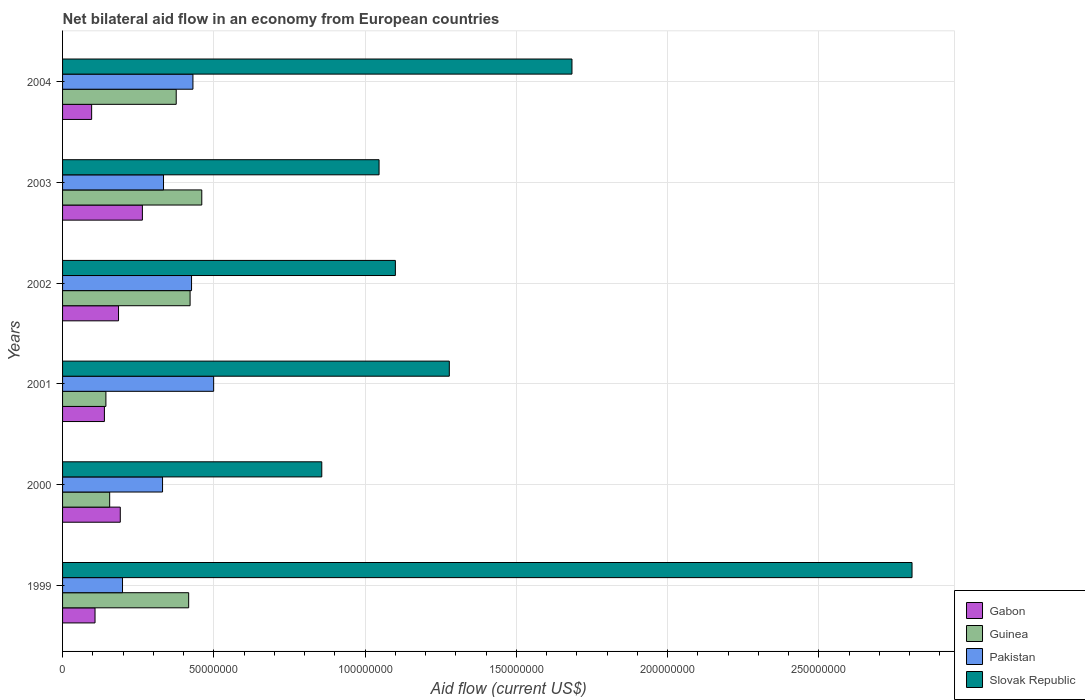How many groups of bars are there?
Provide a short and direct response. 6. Are the number of bars on each tick of the Y-axis equal?
Keep it short and to the point. Yes. How many bars are there on the 5th tick from the top?
Make the answer very short. 4. How many bars are there on the 5th tick from the bottom?
Your response must be concise. 4. In how many cases, is the number of bars for a given year not equal to the number of legend labels?
Your answer should be very brief. 0. What is the net bilateral aid flow in Slovak Republic in 2000?
Offer a very short reply. 8.57e+07. Across all years, what is the maximum net bilateral aid flow in Gabon?
Your answer should be very brief. 2.64e+07. Across all years, what is the minimum net bilateral aid flow in Guinea?
Provide a succinct answer. 1.43e+07. What is the total net bilateral aid flow in Gabon in the graph?
Provide a short and direct response. 9.81e+07. What is the difference between the net bilateral aid flow in Pakistan in 2003 and that in 2004?
Keep it short and to the point. -9.73e+06. What is the difference between the net bilateral aid flow in Pakistan in 2000 and the net bilateral aid flow in Slovak Republic in 2001?
Provide a succinct answer. -9.48e+07. What is the average net bilateral aid flow in Slovak Republic per year?
Your answer should be compact. 1.46e+08. In the year 2000, what is the difference between the net bilateral aid flow in Pakistan and net bilateral aid flow in Gabon?
Make the answer very short. 1.40e+07. In how many years, is the net bilateral aid flow in Guinea greater than 250000000 US$?
Your answer should be very brief. 0. What is the ratio of the net bilateral aid flow in Guinea in 2000 to that in 2001?
Your response must be concise. 1.09. Is the net bilateral aid flow in Slovak Republic in 2000 less than that in 2002?
Make the answer very short. Yes. Is the difference between the net bilateral aid flow in Pakistan in 2001 and 2003 greater than the difference between the net bilateral aid flow in Gabon in 2001 and 2003?
Provide a succinct answer. Yes. What is the difference between the highest and the second highest net bilateral aid flow in Slovak Republic?
Keep it short and to the point. 1.12e+08. What is the difference between the highest and the lowest net bilateral aid flow in Guinea?
Provide a short and direct response. 3.17e+07. In how many years, is the net bilateral aid flow in Slovak Republic greater than the average net bilateral aid flow in Slovak Republic taken over all years?
Provide a short and direct response. 2. Is the sum of the net bilateral aid flow in Slovak Republic in 2000 and 2003 greater than the maximum net bilateral aid flow in Pakistan across all years?
Give a very brief answer. Yes. Is it the case that in every year, the sum of the net bilateral aid flow in Guinea and net bilateral aid flow in Slovak Republic is greater than the sum of net bilateral aid flow in Gabon and net bilateral aid flow in Pakistan?
Offer a very short reply. Yes. What does the 3rd bar from the top in 2004 represents?
Keep it short and to the point. Guinea. What does the 4th bar from the bottom in 2003 represents?
Ensure brevity in your answer.  Slovak Republic. How many bars are there?
Provide a short and direct response. 24. Are all the bars in the graph horizontal?
Offer a very short reply. Yes. How many years are there in the graph?
Make the answer very short. 6. Are the values on the major ticks of X-axis written in scientific E-notation?
Keep it short and to the point. No. Where does the legend appear in the graph?
Offer a very short reply. Bottom right. How many legend labels are there?
Provide a succinct answer. 4. What is the title of the graph?
Ensure brevity in your answer.  Net bilateral aid flow in an economy from European countries. Does "Russian Federation" appear as one of the legend labels in the graph?
Your answer should be very brief. No. What is the Aid flow (current US$) of Gabon in 1999?
Your answer should be compact. 1.07e+07. What is the Aid flow (current US$) in Guinea in 1999?
Your answer should be compact. 4.17e+07. What is the Aid flow (current US$) of Pakistan in 1999?
Offer a very short reply. 1.98e+07. What is the Aid flow (current US$) in Slovak Republic in 1999?
Provide a short and direct response. 2.81e+08. What is the Aid flow (current US$) of Gabon in 2000?
Your answer should be very brief. 1.91e+07. What is the Aid flow (current US$) of Guinea in 2000?
Your answer should be compact. 1.56e+07. What is the Aid flow (current US$) of Pakistan in 2000?
Give a very brief answer. 3.30e+07. What is the Aid flow (current US$) in Slovak Republic in 2000?
Make the answer very short. 8.57e+07. What is the Aid flow (current US$) of Gabon in 2001?
Give a very brief answer. 1.38e+07. What is the Aid flow (current US$) of Guinea in 2001?
Your answer should be compact. 1.43e+07. What is the Aid flow (current US$) of Pakistan in 2001?
Offer a very short reply. 5.00e+07. What is the Aid flow (current US$) in Slovak Republic in 2001?
Give a very brief answer. 1.28e+08. What is the Aid flow (current US$) in Gabon in 2002?
Your answer should be compact. 1.85e+07. What is the Aid flow (current US$) in Guinea in 2002?
Offer a terse response. 4.22e+07. What is the Aid flow (current US$) of Pakistan in 2002?
Make the answer very short. 4.26e+07. What is the Aid flow (current US$) in Slovak Republic in 2002?
Provide a short and direct response. 1.10e+08. What is the Aid flow (current US$) of Gabon in 2003?
Your response must be concise. 2.64e+07. What is the Aid flow (current US$) in Guinea in 2003?
Offer a very short reply. 4.60e+07. What is the Aid flow (current US$) in Pakistan in 2003?
Provide a succinct answer. 3.34e+07. What is the Aid flow (current US$) in Slovak Republic in 2003?
Offer a terse response. 1.05e+08. What is the Aid flow (current US$) of Gabon in 2004?
Keep it short and to the point. 9.61e+06. What is the Aid flow (current US$) in Guinea in 2004?
Your response must be concise. 3.76e+07. What is the Aid flow (current US$) of Pakistan in 2004?
Your response must be concise. 4.31e+07. What is the Aid flow (current US$) in Slovak Republic in 2004?
Offer a terse response. 1.68e+08. Across all years, what is the maximum Aid flow (current US$) of Gabon?
Your answer should be very brief. 2.64e+07. Across all years, what is the maximum Aid flow (current US$) of Guinea?
Keep it short and to the point. 4.60e+07. Across all years, what is the maximum Aid flow (current US$) in Pakistan?
Offer a very short reply. 5.00e+07. Across all years, what is the maximum Aid flow (current US$) of Slovak Republic?
Offer a terse response. 2.81e+08. Across all years, what is the minimum Aid flow (current US$) of Gabon?
Offer a very short reply. 9.61e+06. Across all years, what is the minimum Aid flow (current US$) in Guinea?
Keep it short and to the point. 1.43e+07. Across all years, what is the minimum Aid flow (current US$) in Pakistan?
Your response must be concise. 1.98e+07. Across all years, what is the minimum Aid flow (current US$) in Slovak Republic?
Your answer should be very brief. 8.57e+07. What is the total Aid flow (current US$) in Gabon in the graph?
Give a very brief answer. 9.81e+07. What is the total Aid flow (current US$) in Guinea in the graph?
Offer a very short reply. 1.97e+08. What is the total Aid flow (current US$) in Pakistan in the graph?
Your answer should be very brief. 2.22e+08. What is the total Aid flow (current US$) of Slovak Republic in the graph?
Offer a terse response. 8.77e+08. What is the difference between the Aid flow (current US$) in Gabon in 1999 and that in 2000?
Your answer should be compact. -8.35e+06. What is the difference between the Aid flow (current US$) in Guinea in 1999 and that in 2000?
Ensure brevity in your answer.  2.61e+07. What is the difference between the Aid flow (current US$) in Pakistan in 1999 and that in 2000?
Your answer should be compact. -1.32e+07. What is the difference between the Aid flow (current US$) in Slovak Republic in 1999 and that in 2000?
Provide a short and direct response. 1.95e+08. What is the difference between the Aid flow (current US$) of Gabon in 1999 and that in 2001?
Your answer should be compact. -3.10e+06. What is the difference between the Aid flow (current US$) in Guinea in 1999 and that in 2001?
Make the answer very short. 2.74e+07. What is the difference between the Aid flow (current US$) of Pakistan in 1999 and that in 2001?
Ensure brevity in your answer.  -3.01e+07. What is the difference between the Aid flow (current US$) of Slovak Republic in 1999 and that in 2001?
Give a very brief answer. 1.53e+08. What is the difference between the Aid flow (current US$) of Gabon in 1999 and that in 2002?
Provide a succinct answer. -7.77e+06. What is the difference between the Aid flow (current US$) in Guinea in 1999 and that in 2002?
Keep it short and to the point. -4.70e+05. What is the difference between the Aid flow (current US$) of Pakistan in 1999 and that in 2002?
Offer a very short reply. -2.28e+07. What is the difference between the Aid flow (current US$) in Slovak Republic in 1999 and that in 2002?
Ensure brevity in your answer.  1.71e+08. What is the difference between the Aid flow (current US$) of Gabon in 1999 and that in 2003?
Ensure brevity in your answer.  -1.57e+07. What is the difference between the Aid flow (current US$) of Guinea in 1999 and that in 2003?
Provide a short and direct response. -4.33e+06. What is the difference between the Aid flow (current US$) in Pakistan in 1999 and that in 2003?
Your answer should be compact. -1.36e+07. What is the difference between the Aid flow (current US$) in Slovak Republic in 1999 and that in 2003?
Offer a terse response. 1.76e+08. What is the difference between the Aid flow (current US$) in Gabon in 1999 and that in 2004?
Provide a short and direct response. 1.12e+06. What is the difference between the Aid flow (current US$) of Guinea in 1999 and that in 2004?
Provide a short and direct response. 4.12e+06. What is the difference between the Aid flow (current US$) of Pakistan in 1999 and that in 2004?
Provide a succinct answer. -2.33e+07. What is the difference between the Aid flow (current US$) of Slovak Republic in 1999 and that in 2004?
Your answer should be compact. 1.12e+08. What is the difference between the Aid flow (current US$) in Gabon in 2000 and that in 2001?
Give a very brief answer. 5.25e+06. What is the difference between the Aid flow (current US$) of Guinea in 2000 and that in 2001?
Your answer should be very brief. 1.24e+06. What is the difference between the Aid flow (current US$) of Pakistan in 2000 and that in 2001?
Provide a short and direct response. -1.69e+07. What is the difference between the Aid flow (current US$) in Slovak Republic in 2000 and that in 2001?
Provide a short and direct response. -4.22e+07. What is the difference between the Aid flow (current US$) of Gabon in 2000 and that in 2002?
Make the answer very short. 5.80e+05. What is the difference between the Aid flow (current US$) in Guinea in 2000 and that in 2002?
Provide a succinct answer. -2.66e+07. What is the difference between the Aid flow (current US$) in Pakistan in 2000 and that in 2002?
Your answer should be very brief. -9.59e+06. What is the difference between the Aid flow (current US$) of Slovak Republic in 2000 and that in 2002?
Make the answer very short. -2.43e+07. What is the difference between the Aid flow (current US$) in Gabon in 2000 and that in 2003?
Give a very brief answer. -7.31e+06. What is the difference between the Aid flow (current US$) of Guinea in 2000 and that in 2003?
Offer a terse response. -3.04e+07. What is the difference between the Aid flow (current US$) in Pakistan in 2000 and that in 2003?
Make the answer very short. -3.20e+05. What is the difference between the Aid flow (current US$) in Slovak Republic in 2000 and that in 2003?
Keep it short and to the point. -1.89e+07. What is the difference between the Aid flow (current US$) in Gabon in 2000 and that in 2004?
Ensure brevity in your answer.  9.47e+06. What is the difference between the Aid flow (current US$) in Guinea in 2000 and that in 2004?
Provide a succinct answer. -2.20e+07. What is the difference between the Aid flow (current US$) of Pakistan in 2000 and that in 2004?
Your response must be concise. -1.00e+07. What is the difference between the Aid flow (current US$) of Slovak Republic in 2000 and that in 2004?
Keep it short and to the point. -8.27e+07. What is the difference between the Aid flow (current US$) in Gabon in 2001 and that in 2002?
Provide a succinct answer. -4.67e+06. What is the difference between the Aid flow (current US$) in Guinea in 2001 and that in 2002?
Your answer should be very brief. -2.78e+07. What is the difference between the Aid flow (current US$) in Pakistan in 2001 and that in 2002?
Ensure brevity in your answer.  7.31e+06. What is the difference between the Aid flow (current US$) of Slovak Republic in 2001 and that in 2002?
Your answer should be compact. 1.78e+07. What is the difference between the Aid flow (current US$) of Gabon in 2001 and that in 2003?
Make the answer very short. -1.26e+07. What is the difference between the Aid flow (current US$) in Guinea in 2001 and that in 2003?
Offer a terse response. -3.17e+07. What is the difference between the Aid flow (current US$) in Pakistan in 2001 and that in 2003?
Your response must be concise. 1.66e+07. What is the difference between the Aid flow (current US$) of Slovak Republic in 2001 and that in 2003?
Offer a terse response. 2.32e+07. What is the difference between the Aid flow (current US$) of Gabon in 2001 and that in 2004?
Provide a succinct answer. 4.22e+06. What is the difference between the Aid flow (current US$) of Guinea in 2001 and that in 2004?
Provide a short and direct response. -2.32e+07. What is the difference between the Aid flow (current US$) in Pakistan in 2001 and that in 2004?
Provide a short and direct response. 6.85e+06. What is the difference between the Aid flow (current US$) of Slovak Republic in 2001 and that in 2004?
Offer a very short reply. -4.06e+07. What is the difference between the Aid flow (current US$) of Gabon in 2002 and that in 2003?
Keep it short and to the point. -7.89e+06. What is the difference between the Aid flow (current US$) of Guinea in 2002 and that in 2003?
Provide a short and direct response. -3.86e+06. What is the difference between the Aid flow (current US$) in Pakistan in 2002 and that in 2003?
Keep it short and to the point. 9.27e+06. What is the difference between the Aid flow (current US$) in Slovak Republic in 2002 and that in 2003?
Provide a short and direct response. 5.39e+06. What is the difference between the Aid flow (current US$) of Gabon in 2002 and that in 2004?
Provide a succinct answer. 8.89e+06. What is the difference between the Aid flow (current US$) in Guinea in 2002 and that in 2004?
Give a very brief answer. 4.59e+06. What is the difference between the Aid flow (current US$) in Pakistan in 2002 and that in 2004?
Provide a short and direct response. -4.60e+05. What is the difference between the Aid flow (current US$) in Slovak Republic in 2002 and that in 2004?
Your answer should be very brief. -5.84e+07. What is the difference between the Aid flow (current US$) of Gabon in 2003 and that in 2004?
Offer a very short reply. 1.68e+07. What is the difference between the Aid flow (current US$) of Guinea in 2003 and that in 2004?
Keep it short and to the point. 8.45e+06. What is the difference between the Aid flow (current US$) in Pakistan in 2003 and that in 2004?
Ensure brevity in your answer.  -9.73e+06. What is the difference between the Aid flow (current US$) in Slovak Republic in 2003 and that in 2004?
Keep it short and to the point. -6.38e+07. What is the difference between the Aid flow (current US$) in Gabon in 1999 and the Aid flow (current US$) in Guinea in 2000?
Ensure brevity in your answer.  -4.84e+06. What is the difference between the Aid flow (current US$) of Gabon in 1999 and the Aid flow (current US$) of Pakistan in 2000?
Offer a very short reply. -2.23e+07. What is the difference between the Aid flow (current US$) of Gabon in 1999 and the Aid flow (current US$) of Slovak Republic in 2000?
Make the answer very short. -7.50e+07. What is the difference between the Aid flow (current US$) of Guinea in 1999 and the Aid flow (current US$) of Pakistan in 2000?
Your answer should be compact. 8.64e+06. What is the difference between the Aid flow (current US$) of Guinea in 1999 and the Aid flow (current US$) of Slovak Republic in 2000?
Offer a very short reply. -4.40e+07. What is the difference between the Aid flow (current US$) in Pakistan in 1999 and the Aid flow (current US$) in Slovak Republic in 2000?
Ensure brevity in your answer.  -6.59e+07. What is the difference between the Aid flow (current US$) in Gabon in 1999 and the Aid flow (current US$) in Guinea in 2001?
Provide a short and direct response. -3.60e+06. What is the difference between the Aid flow (current US$) in Gabon in 1999 and the Aid flow (current US$) in Pakistan in 2001?
Keep it short and to the point. -3.92e+07. What is the difference between the Aid flow (current US$) of Gabon in 1999 and the Aid flow (current US$) of Slovak Republic in 2001?
Provide a short and direct response. -1.17e+08. What is the difference between the Aid flow (current US$) in Guinea in 1999 and the Aid flow (current US$) in Pakistan in 2001?
Offer a very short reply. -8.26e+06. What is the difference between the Aid flow (current US$) of Guinea in 1999 and the Aid flow (current US$) of Slovak Republic in 2001?
Provide a short and direct response. -8.62e+07. What is the difference between the Aid flow (current US$) in Pakistan in 1999 and the Aid flow (current US$) in Slovak Republic in 2001?
Your answer should be compact. -1.08e+08. What is the difference between the Aid flow (current US$) of Gabon in 1999 and the Aid flow (current US$) of Guinea in 2002?
Provide a succinct answer. -3.14e+07. What is the difference between the Aid flow (current US$) in Gabon in 1999 and the Aid flow (current US$) in Pakistan in 2002?
Ensure brevity in your answer.  -3.19e+07. What is the difference between the Aid flow (current US$) of Gabon in 1999 and the Aid flow (current US$) of Slovak Republic in 2002?
Offer a very short reply. -9.93e+07. What is the difference between the Aid flow (current US$) of Guinea in 1999 and the Aid flow (current US$) of Pakistan in 2002?
Keep it short and to the point. -9.50e+05. What is the difference between the Aid flow (current US$) in Guinea in 1999 and the Aid flow (current US$) in Slovak Republic in 2002?
Make the answer very short. -6.83e+07. What is the difference between the Aid flow (current US$) of Pakistan in 1999 and the Aid flow (current US$) of Slovak Republic in 2002?
Ensure brevity in your answer.  -9.02e+07. What is the difference between the Aid flow (current US$) of Gabon in 1999 and the Aid flow (current US$) of Guinea in 2003?
Your answer should be compact. -3.53e+07. What is the difference between the Aid flow (current US$) in Gabon in 1999 and the Aid flow (current US$) in Pakistan in 2003?
Keep it short and to the point. -2.26e+07. What is the difference between the Aid flow (current US$) of Gabon in 1999 and the Aid flow (current US$) of Slovak Republic in 2003?
Your answer should be compact. -9.39e+07. What is the difference between the Aid flow (current US$) of Guinea in 1999 and the Aid flow (current US$) of Pakistan in 2003?
Ensure brevity in your answer.  8.32e+06. What is the difference between the Aid flow (current US$) of Guinea in 1999 and the Aid flow (current US$) of Slovak Republic in 2003?
Offer a very short reply. -6.29e+07. What is the difference between the Aid flow (current US$) in Pakistan in 1999 and the Aid flow (current US$) in Slovak Republic in 2003?
Make the answer very short. -8.48e+07. What is the difference between the Aid flow (current US$) of Gabon in 1999 and the Aid flow (current US$) of Guinea in 2004?
Give a very brief answer. -2.68e+07. What is the difference between the Aid flow (current US$) in Gabon in 1999 and the Aid flow (current US$) in Pakistan in 2004?
Give a very brief answer. -3.24e+07. What is the difference between the Aid flow (current US$) in Gabon in 1999 and the Aid flow (current US$) in Slovak Republic in 2004?
Make the answer very short. -1.58e+08. What is the difference between the Aid flow (current US$) in Guinea in 1999 and the Aid flow (current US$) in Pakistan in 2004?
Provide a short and direct response. -1.41e+06. What is the difference between the Aid flow (current US$) in Guinea in 1999 and the Aid flow (current US$) in Slovak Republic in 2004?
Make the answer very short. -1.27e+08. What is the difference between the Aid flow (current US$) in Pakistan in 1999 and the Aid flow (current US$) in Slovak Republic in 2004?
Keep it short and to the point. -1.49e+08. What is the difference between the Aid flow (current US$) in Gabon in 2000 and the Aid flow (current US$) in Guinea in 2001?
Offer a very short reply. 4.75e+06. What is the difference between the Aid flow (current US$) in Gabon in 2000 and the Aid flow (current US$) in Pakistan in 2001?
Give a very brief answer. -3.09e+07. What is the difference between the Aid flow (current US$) in Gabon in 2000 and the Aid flow (current US$) in Slovak Republic in 2001?
Provide a short and direct response. -1.09e+08. What is the difference between the Aid flow (current US$) of Guinea in 2000 and the Aid flow (current US$) of Pakistan in 2001?
Provide a succinct answer. -3.44e+07. What is the difference between the Aid flow (current US$) of Guinea in 2000 and the Aid flow (current US$) of Slovak Republic in 2001?
Offer a terse response. -1.12e+08. What is the difference between the Aid flow (current US$) of Pakistan in 2000 and the Aid flow (current US$) of Slovak Republic in 2001?
Give a very brief answer. -9.48e+07. What is the difference between the Aid flow (current US$) of Gabon in 2000 and the Aid flow (current US$) of Guinea in 2002?
Give a very brief answer. -2.31e+07. What is the difference between the Aid flow (current US$) in Gabon in 2000 and the Aid flow (current US$) in Pakistan in 2002?
Provide a short and direct response. -2.36e+07. What is the difference between the Aid flow (current US$) in Gabon in 2000 and the Aid flow (current US$) in Slovak Republic in 2002?
Make the answer very short. -9.09e+07. What is the difference between the Aid flow (current US$) of Guinea in 2000 and the Aid flow (current US$) of Pakistan in 2002?
Ensure brevity in your answer.  -2.71e+07. What is the difference between the Aid flow (current US$) in Guinea in 2000 and the Aid flow (current US$) in Slovak Republic in 2002?
Your answer should be compact. -9.44e+07. What is the difference between the Aid flow (current US$) of Pakistan in 2000 and the Aid flow (current US$) of Slovak Republic in 2002?
Your answer should be very brief. -7.70e+07. What is the difference between the Aid flow (current US$) of Gabon in 2000 and the Aid flow (current US$) of Guinea in 2003?
Offer a very short reply. -2.69e+07. What is the difference between the Aid flow (current US$) in Gabon in 2000 and the Aid flow (current US$) in Pakistan in 2003?
Offer a terse response. -1.43e+07. What is the difference between the Aid flow (current US$) of Gabon in 2000 and the Aid flow (current US$) of Slovak Republic in 2003?
Provide a short and direct response. -8.56e+07. What is the difference between the Aid flow (current US$) in Guinea in 2000 and the Aid flow (current US$) in Pakistan in 2003?
Your answer should be compact. -1.78e+07. What is the difference between the Aid flow (current US$) in Guinea in 2000 and the Aid flow (current US$) in Slovak Republic in 2003?
Ensure brevity in your answer.  -8.91e+07. What is the difference between the Aid flow (current US$) of Pakistan in 2000 and the Aid flow (current US$) of Slovak Republic in 2003?
Ensure brevity in your answer.  -7.16e+07. What is the difference between the Aid flow (current US$) in Gabon in 2000 and the Aid flow (current US$) in Guinea in 2004?
Your answer should be very brief. -1.85e+07. What is the difference between the Aid flow (current US$) in Gabon in 2000 and the Aid flow (current US$) in Pakistan in 2004?
Your response must be concise. -2.40e+07. What is the difference between the Aid flow (current US$) in Gabon in 2000 and the Aid flow (current US$) in Slovak Republic in 2004?
Offer a terse response. -1.49e+08. What is the difference between the Aid flow (current US$) in Guinea in 2000 and the Aid flow (current US$) in Pakistan in 2004?
Provide a succinct answer. -2.75e+07. What is the difference between the Aid flow (current US$) of Guinea in 2000 and the Aid flow (current US$) of Slovak Republic in 2004?
Your answer should be compact. -1.53e+08. What is the difference between the Aid flow (current US$) of Pakistan in 2000 and the Aid flow (current US$) of Slovak Republic in 2004?
Provide a succinct answer. -1.35e+08. What is the difference between the Aid flow (current US$) of Gabon in 2001 and the Aid flow (current US$) of Guinea in 2002?
Keep it short and to the point. -2.83e+07. What is the difference between the Aid flow (current US$) in Gabon in 2001 and the Aid flow (current US$) in Pakistan in 2002?
Provide a succinct answer. -2.88e+07. What is the difference between the Aid flow (current US$) of Gabon in 2001 and the Aid flow (current US$) of Slovak Republic in 2002?
Provide a succinct answer. -9.62e+07. What is the difference between the Aid flow (current US$) of Guinea in 2001 and the Aid flow (current US$) of Pakistan in 2002?
Your answer should be compact. -2.83e+07. What is the difference between the Aid flow (current US$) of Guinea in 2001 and the Aid flow (current US$) of Slovak Republic in 2002?
Your answer should be very brief. -9.57e+07. What is the difference between the Aid flow (current US$) of Pakistan in 2001 and the Aid flow (current US$) of Slovak Republic in 2002?
Your response must be concise. -6.01e+07. What is the difference between the Aid flow (current US$) of Gabon in 2001 and the Aid flow (current US$) of Guinea in 2003?
Offer a terse response. -3.22e+07. What is the difference between the Aid flow (current US$) in Gabon in 2001 and the Aid flow (current US$) in Pakistan in 2003?
Offer a very short reply. -1.95e+07. What is the difference between the Aid flow (current US$) in Gabon in 2001 and the Aid flow (current US$) in Slovak Republic in 2003?
Keep it short and to the point. -9.08e+07. What is the difference between the Aid flow (current US$) in Guinea in 2001 and the Aid flow (current US$) in Pakistan in 2003?
Provide a short and direct response. -1.90e+07. What is the difference between the Aid flow (current US$) of Guinea in 2001 and the Aid flow (current US$) of Slovak Republic in 2003?
Offer a terse response. -9.03e+07. What is the difference between the Aid flow (current US$) of Pakistan in 2001 and the Aid flow (current US$) of Slovak Republic in 2003?
Keep it short and to the point. -5.47e+07. What is the difference between the Aid flow (current US$) in Gabon in 2001 and the Aid flow (current US$) in Guinea in 2004?
Ensure brevity in your answer.  -2.37e+07. What is the difference between the Aid flow (current US$) of Gabon in 2001 and the Aid flow (current US$) of Pakistan in 2004?
Your answer should be compact. -2.93e+07. What is the difference between the Aid flow (current US$) of Gabon in 2001 and the Aid flow (current US$) of Slovak Republic in 2004?
Offer a very short reply. -1.55e+08. What is the difference between the Aid flow (current US$) of Guinea in 2001 and the Aid flow (current US$) of Pakistan in 2004?
Provide a short and direct response. -2.88e+07. What is the difference between the Aid flow (current US$) in Guinea in 2001 and the Aid flow (current US$) in Slovak Republic in 2004?
Offer a terse response. -1.54e+08. What is the difference between the Aid flow (current US$) of Pakistan in 2001 and the Aid flow (current US$) of Slovak Republic in 2004?
Your response must be concise. -1.18e+08. What is the difference between the Aid flow (current US$) of Gabon in 2002 and the Aid flow (current US$) of Guinea in 2003?
Offer a very short reply. -2.75e+07. What is the difference between the Aid flow (current US$) of Gabon in 2002 and the Aid flow (current US$) of Pakistan in 2003?
Offer a terse response. -1.49e+07. What is the difference between the Aid flow (current US$) of Gabon in 2002 and the Aid flow (current US$) of Slovak Republic in 2003?
Your answer should be compact. -8.61e+07. What is the difference between the Aid flow (current US$) in Guinea in 2002 and the Aid flow (current US$) in Pakistan in 2003?
Offer a terse response. 8.79e+06. What is the difference between the Aid flow (current US$) of Guinea in 2002 and the Aid flow (current US$) of Slovak Republic in 2003?
Provide a succinct answer. -6.25e+07. What is the difference between the Aid flow (current US$) of Pakistan in 2002 and the Aid flow (current US$) of Slovak Republic in 2003?
Offer a very short reply. -6.20e+07. What is the difference between the Aid flow (current US$) of Gabon in 2002 and the Aid flow (current US$) of Guinea in 2004?
Give a very brief answer. -1.91e+07. What is the difference between the Aid flow (current US$) of Gabon in 2002 and the Aid flow (current US$) of Pakistan in 2004?
Ensure brevity in your answer.  -2.46e+07. What is the difference between the Aid flow (current US$) of Gabon in 2002 and the Aid flow (current US$) of Slovak Republic in 2004?
Your response must be concise. -1.50e+08. What is the difference between the Aid flow (current US$) of Guinea in 2002 and the Aid flow (current US$) of Pakistan in 2004?
Your response must be concise. -9.40e+05. What is the difference between the Aid flow (current US$) in Guinea in 2002 and the Aid flow (current US$) in Slovak Republic in 2004?
Provide a succinct answer. -1.26e+08. What is the difference between the Aid flow (current US$) in Pakistan in 2002 and the Aid flow (current US$) in Slovak Republic in 2004?
Your answer should be compact. -1.26e+08. What is the difference between the Aid flow (current US$) of Gabon in 2003 and the Aid flow (current US$) of Guinea in 2004?
Your response must be concise. -1.12e+07. What is the difference between the Aid flow (current US$) in Gabon in 2003 and the Aid flow (current US$) in Pakistan in 2004?
Your response must be concise. -1.67e+07. What is the difference between the Aid flow (current US$) in Gabon in 2003 and the Aid flow (current US$) in Slovak Republic in 2004?
Make the answer very short. -1.42e+08. What is the difference between the Aid flow (current US$) of Guinea in 2003 and the Aid flow (current US$) of Pakistan in 2004?
Your answer should be compact. 2.92e+06. What is the difference between the Aid flow (current US$) in Guinea in 2003 and the Aid flow (current US$) in Slovak Republic in 2004?
Make the answer very short. -1.22e+08. What is the difference between the Aid flow (current US$) in Pakistan in 2003 and the Aid flow (current US$) in Slovak Republic in 2004?
Your answer should be compact. -1.35e+08. What is the average Aid flow (current US$) of Gabon per year?
Your answer should be very brief. 1.64e+07. What is the average Aid flow (current US$) of Guinea per year?
Your response must be concise. 3.29e+07. What is the average Aid flow (current US$) of Pakistan per year?
Keep it short and to the point. 3.70e+07. What is the average Aid flow (current US$) of Slovak Republic per year?
Provide a short and direct response. 1.46e+08. In the year 1999, what is the difference between the Aid flow (current US$) of Gabon and Aid flow (current US$) of Guinea?
Give a very brief answer. -3.10e+07. In the year 1999, what is the difference between the Aid flow (current US$) of Gabon and Aid flow (current US$) of Pakistan?
Your answer should be very brief. -9.09e+06. In the year 1999, what is the difference between the Aid flow (current US$) in Gabon and Aid flow (current US$) in Slovak Republic?
Make the answer very short. -2.70e+08. In the year 1999, what is the difference between the Aid flow (current US$) in Guinea and Aid flow (current US$) in Pakistan?
Ensure brevity in your answer.  2.19e+07. In the year 1999, what is the difference between the Aid flow (current US$) in Guinea and Aid flow (current US$) in Slovak Republic?
Keep it short and to the point. -2.39e+08. In the year 1999, what is the difference between the Aid flow (current US$) of Pakistan and Aid flow (current US$) of Slovak Republic?
Offer a very short reply. -2.61e+08. In the year 2000, what is the difference between the Aid flow (current US$) in Gabon and Aid flow (current US$) in Guinea?
Provide a succinct answer. 3.51e+06. In the year 2000, what is the difference between the Aid flow (current US$) in Gabon and Aid flow (current US$) in Pakistan?
Make the answer very short. -1.40e+07. In the year 2000, what is the difference between the Aid flow (current US$) of Gabon and Aid flow (current US$) of Slovak Republic?
Keep it short and to the point. -6.66e+07. In the year 2000, what is the difference between the Aid flow (current US$) in Guinea and Aid flow (current US$) in Pakistan?
Your answer should be very brief. -1.75e+07. In the year 2000, what is the difference between the Aid flow (current US$) of Guinea and Aid flow (current US$) of Slovak Republic?
Ensure brevity in your answer.  -7.01e+07. In the year 2000, what is the difference between the Aid flow (current US$) in Pakistan and Aid flow (current US$) in Slovak Republic?
Offer a terse response. -5.26e+07. In the year 2001, what is the difference between the Aid flow (current US$) in Gabon and Aid flow (current US$) in Guinea?
Provide a succinct answer. -5.00e+05. In the year 2001, what is the difference between the Aid flow (current US$) of Gabon and Aid flow (current US$) of Pakistan?
Make the answer very short. -3.61e+07. In the year 2001, what is the difference between the Aid flow (current US$) of Gabon and Aid flow (current US$) of Slovak Republic?
Give a very brief answer. -1.14e+08. In the year 2001, what is the difference between the Aid flow (current US$) in Guinea and Aid flow (current US$) in Pakistan?
Provide a short and direct response. -3.56e+07. In the year 2001, what is the difference between the Aid flow (current US$) of Guinea and Aid flow (current US$) of Slovak Republic?
Provide a succinct answer. -1.14e+08. In the year 2001, what is the difference between the Aid flow (current US$) in Pakistan and Aid flow (current US$) in Slovak Republic?
Your response must be concise. -7.79e+07. In the year 2002, what is the difference between the Aid flow (current US$) in Gabon and Aid flow (current US$) in Guinea?
Your answer should be compact. -2.37e+07. In the year 2002, what is the difference between the Aid flow (current US$) of Gabon and Aid flow (current US$) of Pakistan?
Provide a succinct answer. -2.41e+07. In the year 2002, what is the difference between the Aid flow (current US$) in Gabon and Aid flow (current US$) in Slovak Republic?
Your answer should be compact. -9.15e+07. In the year 2002, what is the difference between the Aid flow (current US$) in Guinea and Aid flow (current US$) in Pakistan?
Your answer should be very brief. -4.80e+05. In the year 2002, what is the difference between the Aid flow (current US$) of Guinea and Aid flow (current US$) of Slovak Republic?
Give a very brief answer. -6.79e+07. In the year 2002, what is the difference between the Aid flow (current US$) of Pakistan and Aid flow (current US$) of Slovak Republic?
Offer a very short reply. -6.74e+07. In the year 2003, what is the difference between the Aid flow (current US$) in Gabon and Aid flow (current US$) in Guinea?
Provide a succinct answer. -1.96e+07. In the year 2003, what is the difference between the Aid flow (current US$) in Gabon and Aid flow (current US$) in Pakistan?
Ensure brevity in your answer.  -6.98e+06. In the year 2003, what is the difference between the Aid flow (current US$) in Gabon and Aid flow (current US$) in Slovak Republic?
Make the answer very short. -7.82e+07. In the year 2003, what is the difference between the Aid flow (current US$) of Guinea and Aid flow (current US$) of Pakistan?
Make the answer very short. 1.26e+07. In the year 2003, what is the difference between the Aid flow (current US$) of Guinea and Aid flow (current US$) of Slovak Republic?
Your response must be concise. -5.86e+07. In the year 2003, what is the difference between the Aid flow (current US$) of Pakistan and Aid flow (current US$) of Slovak Republic?
Provide a short and direct response. -7.13e+07. In the year 2004, what is the difference between the Aid flow (current US$) of Gabon and Aid flow (current US$) of Guinea?
Give a very brief answer. -2.80e+07. In the year 2004, what is the difference between the Aid flow (current US$) in Gabon and Aid flow (current US$) in Pakistan?
Offer a terse response. -3.35e+07. In the year 2004, what is the difference between the Aid flow (current US$) of Gabon and Aid flow (current US$) of Slovak Republic?
Provide a succinct answer. -1.59e+08. In the year 2004, what is the difference between the Aid flow (current US$) in Guinea and Aid flow (current US$) in Pakistan?
Keep it short and to the point. -5.53e+06. In the year 2004, what is the difference between the Aid flow (current US$) in Guinea and Aid flow (current US$) in Slovak Republic?
Give a very brief answer. -1.31e+08. In the year 2004, what is the difference between the Aid flow (current US$) of Pakistan and Aid flow (current US$) of Slovak Republic?
Make the answer very short. -1.25e+08. What is the ratio of the Aid flow (current US$) in Gabon in 1999 to that in 2000?
Keep it short and to the point. 0.56. What is the ratio of the Aid flow (current US$) of Guinea in 1999 to that in 2000?
Provide a short and direct response. 2.68. What is the ratio of the Aid flow (current US$) in Pakistan in 1999 to that in 2000?
Keep it short and to the point. 0.6. What is the ratio of the Aid flow (current US$) of Slovak Republic in 1999 to that in 2000?
Ensure brevity in your answer.  3.28. What is the ratio of the Aid flow (current US$) of Gabon in 1999 to that in 2001?
Offer a terse response. 0.78. What is the ratio of the Aid flow (current US$) in Guinea in 1999 to that in 2001?
Offer a terse response. 2.91. What is the ratio of the Aid flow (current US$) in Pakistan in 1999 to that in 2001?
Your answer should be compact. 0.4. What is the ratio of the Aid flow (current US$) in Slovak Republic in 1999 to that in 2001?
Provide a short and direct response. 2.2. What is the ratio of the Aid flow (current US$) in Gabon in 1999 to that in 2002?
Your answer should be compact. 0.58. What is the ratio of the Aid flow (current US$) in Guinea in 1999 to that in 2002?
Make the answer very short. 0.99. What is the ratio of the Aid flow (current US$) in Pakistan in 1999 to that in 2002?
Your response must be concise. 0.46. What is the ratio of the Aid flow (current US$) of Slovak Republic in 1999 to that in 2002?
Offer a terse response. 2.55. What is the ratio of the Aid flow (current US$) of Gabon in 1999 to that in 2003?
Offer a terse response. 0.41. What is the ratio of the Aid flow (current US$) in Guinea in 1999 to that in 2003?
Your answer should be compact. 0.91. What is the ratio of the Aid flow (current US$) in Pakistan in 1999 to that in 2003?
Your answer should be compact. 0.59. What is the ratio of the Aid flow (current US$) in Slovak Republic in 1999 to that in 2003?
Your answer should be compact. 2.68. What is the ratio of the Aid flow (current US$) of Gabon in 1999 to that in 2004?
Your answer should be very brief. 1.12. What is the ratio of the Aid flow (current US$) in Guinea in 1999 to that in 2004?
Offer a very short reply. 1.11. What is the ratio of the Aid flow (current US$) of Pakistan in 1999 to that in 2004?
Provide a short and direct response. 0.46. What is the ratio of the Aid flow (current US$) of Slovak Republic in 1999 to that in 2004?
Provide a short and direct response. 1.67. What is the ratio of the Aid flow (current US$) of Gabon in 2000 to that in 2001?
Keep it short and to the point. 1.38. What is the ratio of the Aid flow (current US$) in Guinea in 2000 to that in 2001?
Give a very brief answer. 1.09. What is the ratio of the Aid flow (current US$) of Pakistan in 2000 to that in 2001?
Your response must be concise. 0.66. What is the ratio of the Aid flow (current US$) in Slovak Republic in 2000 to that in 2001?
Offer a very short reply. 0.67. What is the ratio of the Aid flow (current US$) in Gabon in 2000 to that in 2002?
Your response must be concise. 1.03. What is the ratio of the Aid flow (current US$) in Guinea in 2000 to that in 2002?
Offer a very short reply. 0.37. What is the ratio of the Aid flow (current US$) in Pakistan in 2000 to that in 2002?
Keep it short and to the point. 0.78. What is the ratio of the Aid flow (current US$) of Slovak Republic in 2000 to that in 2002?
Your response must be concise. 0.78. What is the ratio of the Aid flow (current US$) of Gabon in 2000 to that in 2003?
Your answer should be very brief. 0.72. What is the ratio of the Aid flow (current US$) in Guinea in 2000 to that in 2003?
Offer a very short reply. 0.34. What is the ratio of the Aid flow (current US$) in Pakistan in 2000 to that in 2003?
Provide a succinct answer. 0.99. What is the ratio of the Aid flow (current US$) in Slovak Republic in 2000 to that in 2003?
Provide a short and direct response. 0.82. What is the ratio of the Aid flow (current US$) in Gabon in 2000 to that in 2004?
Offer a very short reply. 1.99. What is the ratio of the Aid flow (current US$) of Guinea in 2000 to that in 2004?
Provide a succinct answer. 0.41. What is the ratio of the Aid flow (current US$) of Pakistan in 2000 to that in 2004?
Your answer should be very brief. 0.77. What is the ratio of the Aid flow (current US$) in Slovak Republic in 2000 to that in 2004?
Make the answer very short. 0.51. What is the ratio of the Aid flow (current US$) of Gabon in 2001 to that in 2002?
Ensure brevity in your answer.  0.75. What is the ratio of the Aid flow (current US$) in Guinea in 2001 to that in 2002?
Your answer should be very brief. 0.34. What is the ratio of the Aid flow (current US$) in Pakistan in 2001 to that in 2002?
Your answer should be compact. 1.17. What is the ratio of the Aid flow (current US$) in Slovak Republic in 2001 to that in 2002?
Your answer should be very brief. 1.16. What is the ratio of the Aid flow (current US$) of Gabon in 2001 to that in 2003?
Offer a very short reply. 0.52. What is the ratio of the Aid flow (current US$) in Guinea in 2001 to that in 2003?
Give a very brief answer. 0.31. What is the ratio of the Aid flow (current US$) of Pakistan in 2001 to that in 2003?
Offer a terse response. 1.5. What is the ratio of the Aid flow (current US$) of Slovak Republic in 2001 to that in 2003?
Your answer should be compact. 1.22. What is the ratio of the Aid flow (current US$) in Gabon in 2001 to that in 2004?
Keep it short and to the point. 1.44. What is the ratio of the Aid flow (current US$) of Guinea in 2001 to that in 2004?
Keep it short and to the point. 0.38. What is the ratio of the Aid flow (current US$) in Pakistan in 2001 to that in 2004?
Your answer should be very brief. 1.16. What is the ratio of the Aid flow (current US$) of Slovak Republic in 2001 to that in 2004?
Your answer should be very brief. 0.76. What is the ratio of the Aid flow (current US$) in Gabon in 2002 to that in 2003?
Your answer should be compact. 0.7. What is the ratio of the Aid flow (current US$) in Guinea in 2002 to that in 2003?
Keep it short and to the point. 0.92. What is the ratio of the Aid flow (current US$) in Pakistan in 2002 to that in 2003?
Offer a terse response. 1.28. What is the ratio of the Aid flow (current US$) of Slovak Republic in 2002 to that in 2003?
Offer a terse response. 1.05. What is the ratio of the Aid flow (current US$) in Gabon in 2002 to that in 2004?
Provide a short and direct response. 1.93. What is the ratio of the Aid flow (current US$) in Guinea in 2002 to that in 2004?
Give a very brief answer. 1.12. What is the ratio of the Aid flow (current US$) of Pakistan in 2002 to that in 2004?
Offer a terse response. 0.99. What is the ratio of the Aid flow (current US$) in Slovak Republic in 2002 to that in 2004?
Your answer should be very brief. 0.65. What is the ratio of the Aid flow (current US$) in Gabon in 2003 to that in 2004?
Provide a short and direct response. 2.75. What is the ratio of the Aid flow (current US$) of Guinea in 2003 to that in 2004?
Offer a terse response. 1.22. What is the ratio of the Aid flow (current US$) in Pakistan in 2003 to that in 2004?
Provide a succinct answer. 0.77. What is the ratio of the Aid flow (current US$) in Slovak Republic in 2003 to that in 2004?
Keep it short and to the point. 0.62. What is the difference between the highest and the second highest Aid flow (current US$) in Gabon?
Offer a terse response. 7.31e+06. What is the difference between the highest and the second highest Aid flow (current US$) in Guinea?
Make the answer very short. 3.86e+06. What is the difference between the highest and the second highest Aid flow (current US$) in Pakistan?
Your answer should be compact. 6.85e+06. What is the difference between the highest and the second highest Aid flow (current US$) of Slovak Republic?
Your answer should be very brief. 1.12e+08. What is the difference between the highest and the lowest Aid flow (current US$) of Gabon?
Offer a very short reply. 1.68e+07. What is the difference between the highest and the lowest Aid flow (current US$) of Guinea?
Your response must be concise. 3.17e+07. What is the difference between the highest and the lowest Aid flow (current US$) of Pakistan?
Offer a very short reply. 3.01e+07. What is the difference between the highest and the lowest Aid flow (current US$) of Slovak Republic?
Offer a very short reply. 1.95e+08. 